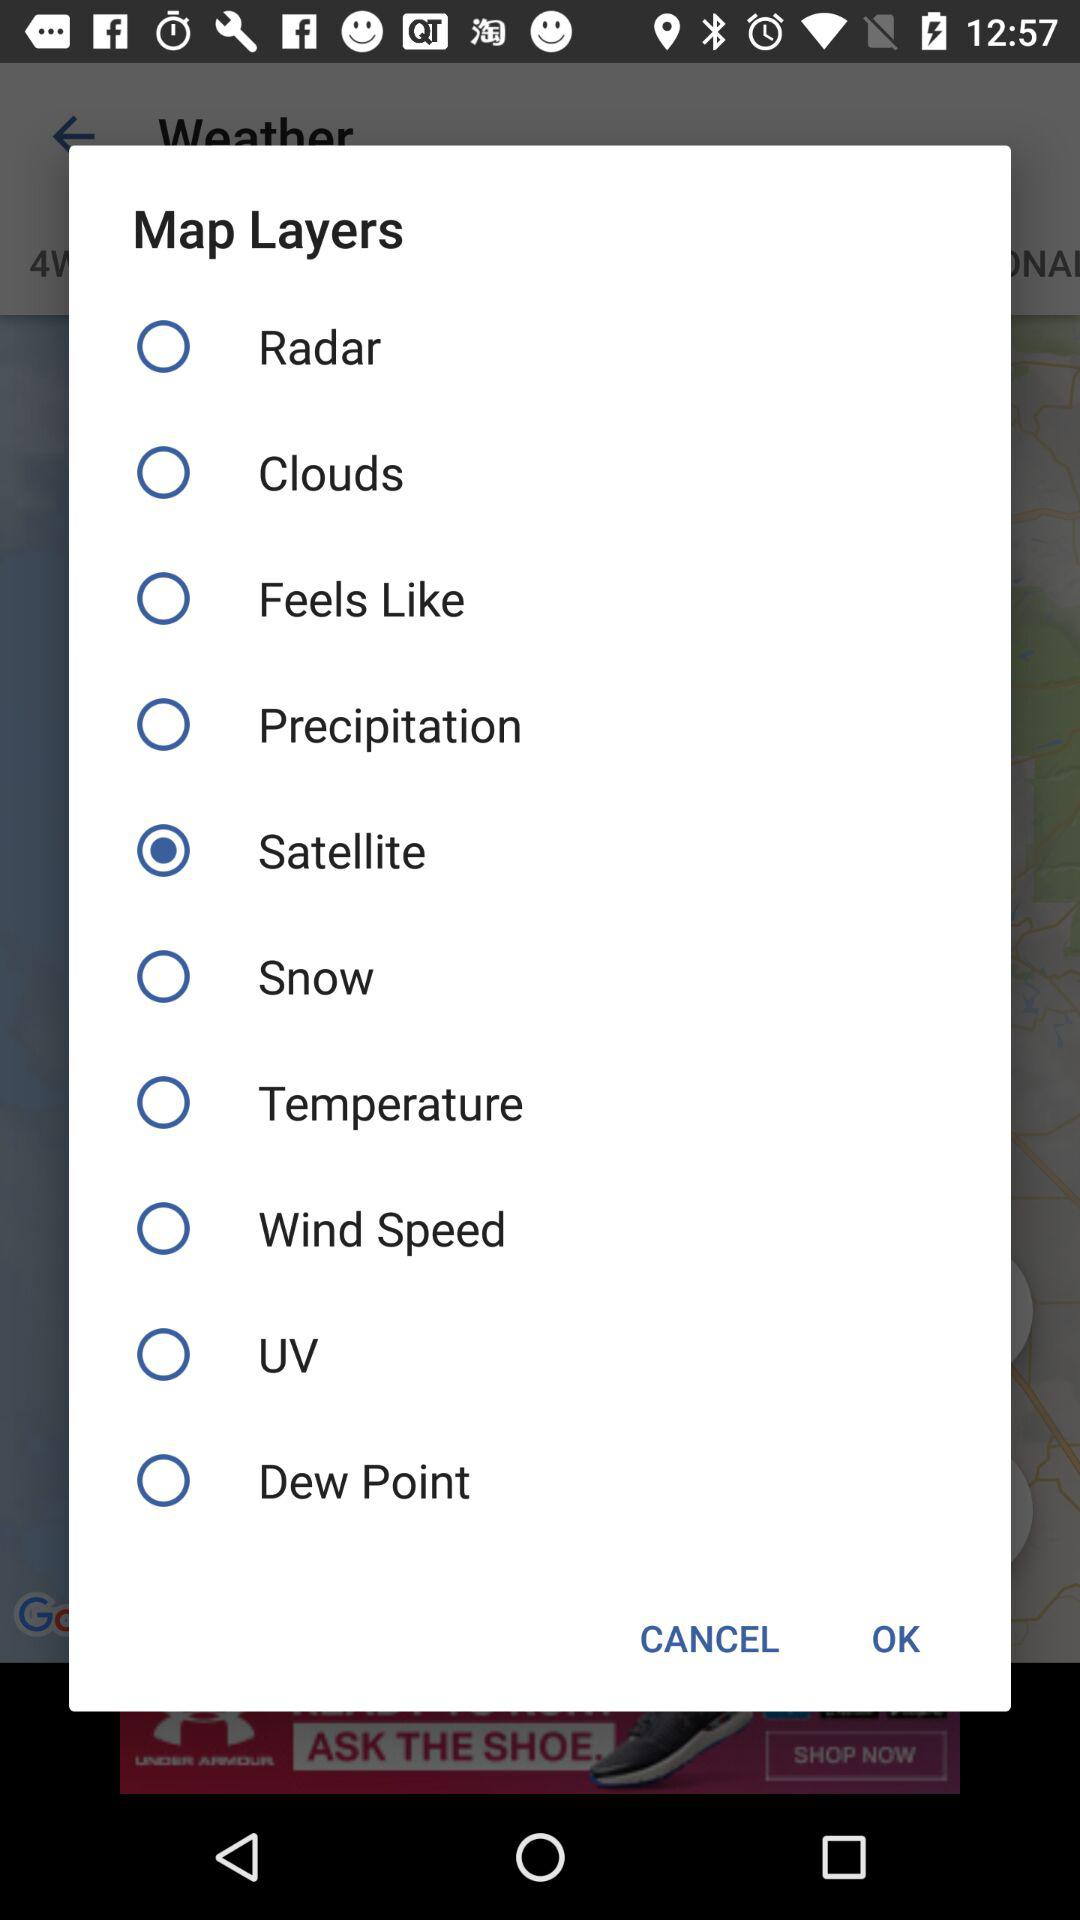Who is this application powered by?
When the provided information is insufficient, respond with <no answer>. <no answer> 